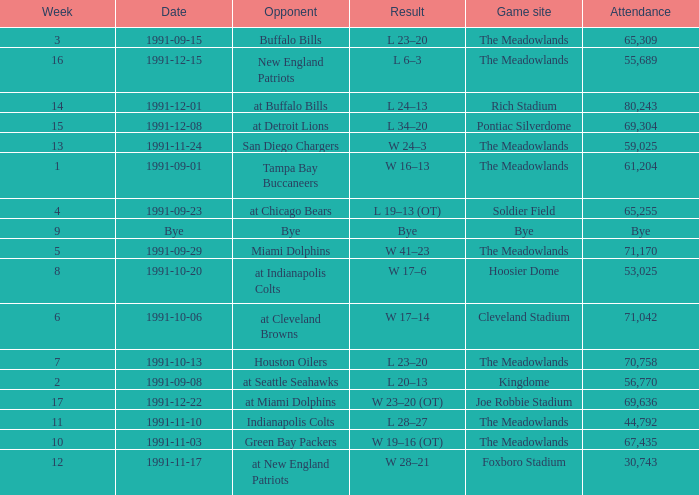What was the Attendance in Week 17? 69636.0. 